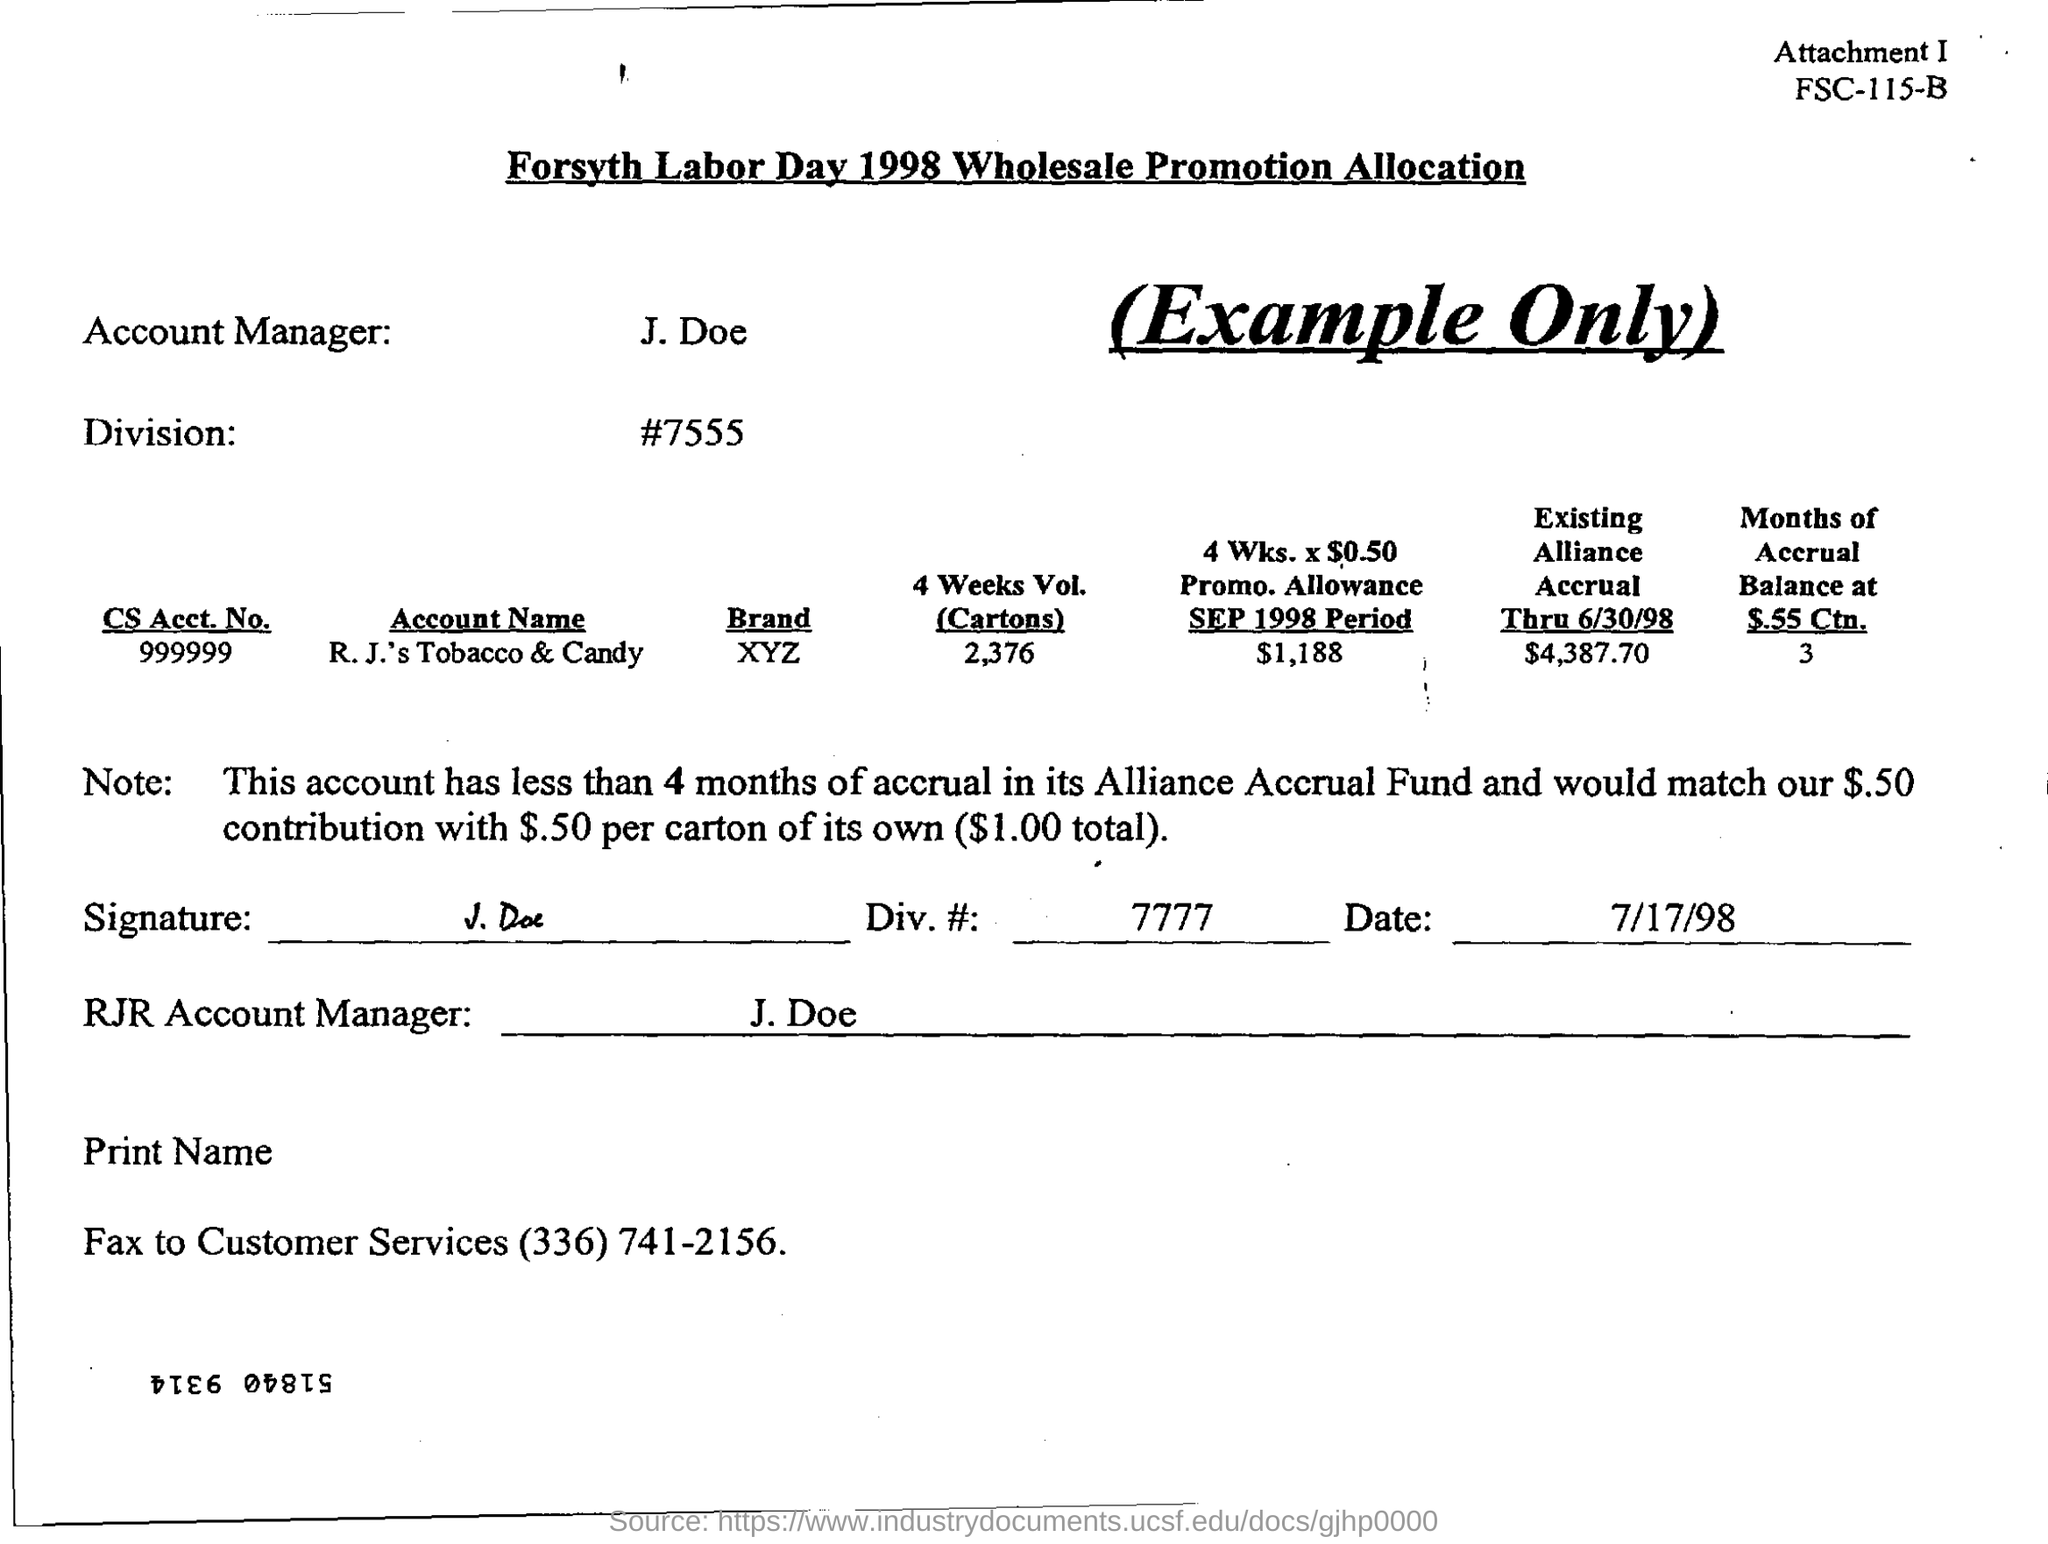Who is the account manager?
Provide a succinct answer. J. Doe. What is the fax no to customer services?
Offer a very short reply. (336) 741-2156. When is the form dated?
Keep it short and to the point. 7/17/98. What is the CS Acct. No. given in the form?
Offer a terse response. 999999. How many months of accrual does this account have in its Alliance Accrual Fund?
Your answer should be very brief. Less than 4 months. 